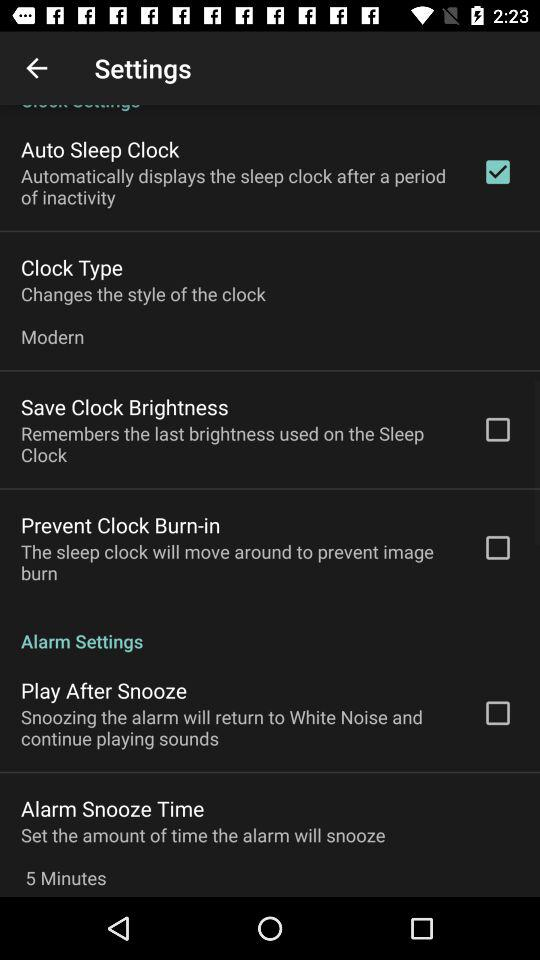What is the status of the save clock brightness? The status of the save clock brightness is off. 